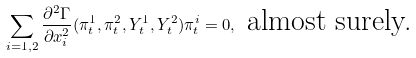Convert formula to latex. <formula><loc_0><loc_0><loc_500><loc_500>\sum _ { i = 1 , 2 } \frac { \partial ^ { 2 } \Gamma } { \partial x _ { i } ^ { 2 } } ( \pi ^ { 1 } _ { t } , \pi ^ { 2 } _ { t } , Y ^ { 1 } _ { t } , Y ^ { 2 } _ { t } ) \pi ^ { i } _ { t } = 0 , \text { almost surely.}</formula> 